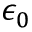Convert formula to latex. <formula><loc_0><loc_0><loc_500><loc_500>\epsilon _ { 0 }</formula> 